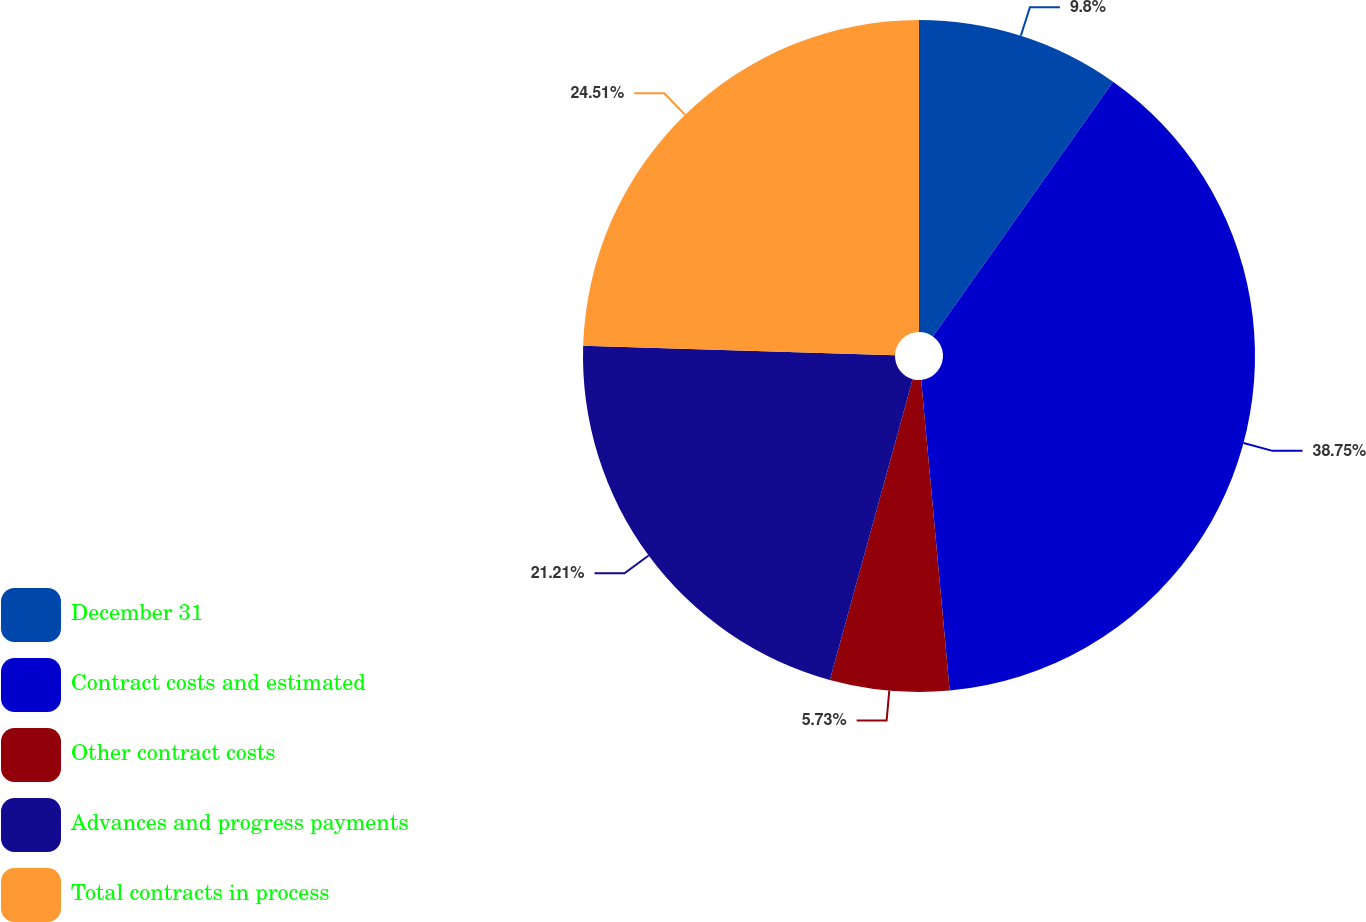Convert chart to OTSL. <chart><loc_0><loc_0><loc_500><loc_500><pie_chart><fcel>December 31<fcel>Contract costs and estimated<fcel>Other contract costs<fcel>Advances and progress payments<fcel>Total contracts in process<nl><fcel>9.8%<fcel>38.74%<fcel>5.73%<fcel>21.21%<fcel>24.51%<nl></chart> 